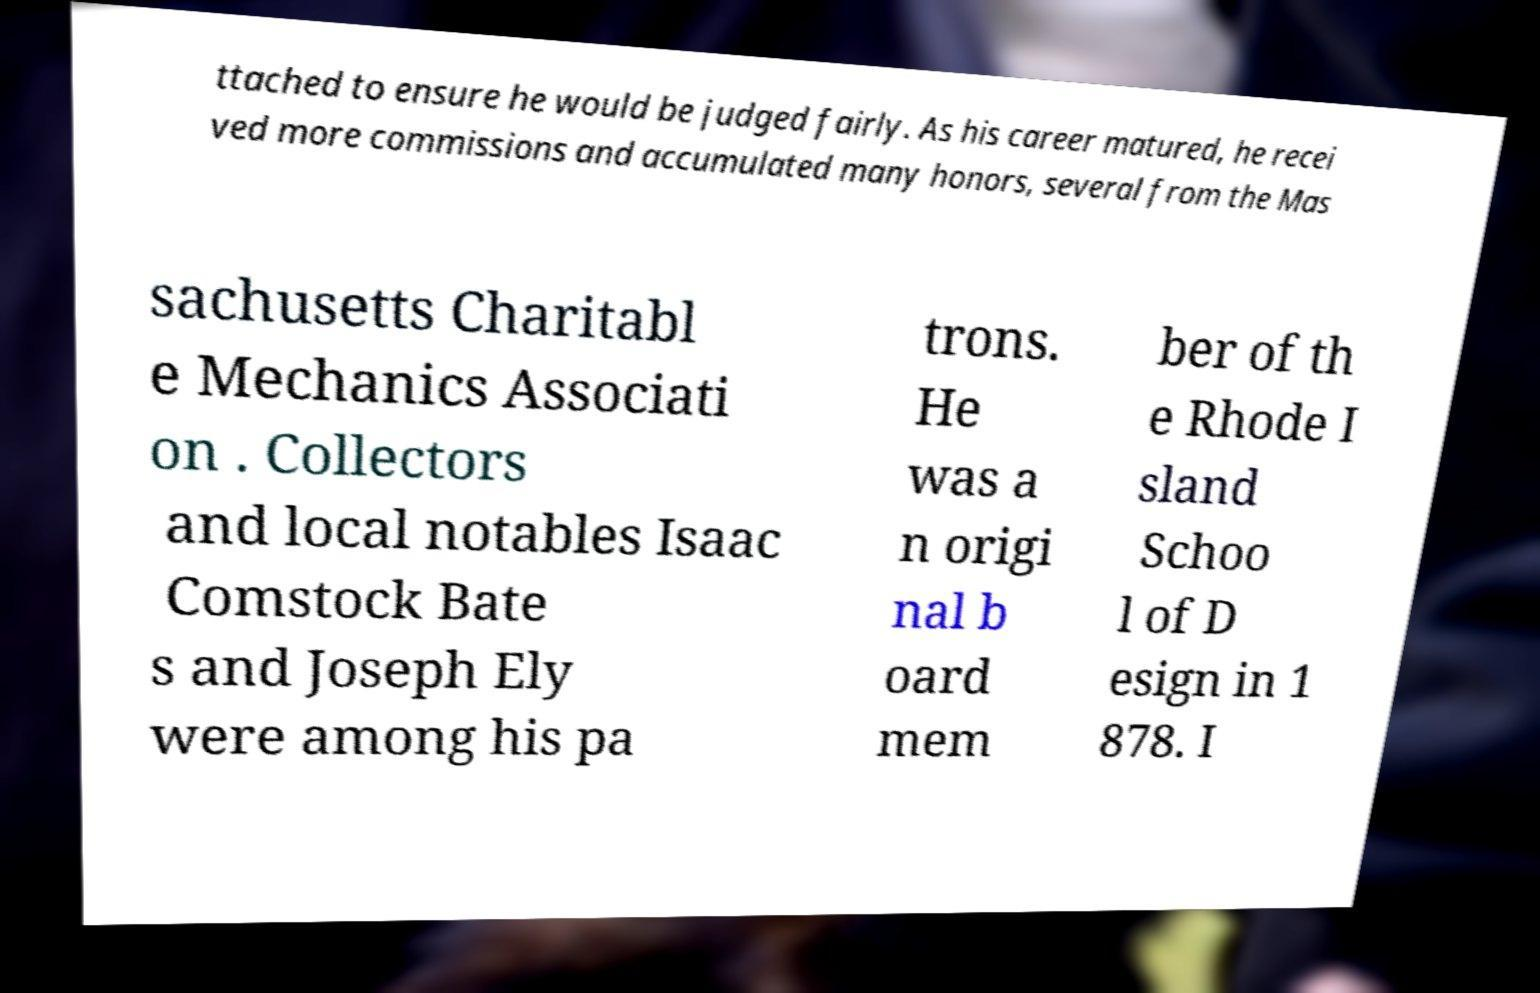Can you read and provide the text displayed in the image?This photo seems to have some interesting text. Can you extract and type it out for me? ttached to ensure he would be judged fairly. As his career matured, he recei ved more commissions and accumulated many honors, several from the Mas sachusetts Charitabl e Mechanics Associati on . Collectors and local notables Isaac Comstock Bate s and Joseph Ely were among his pa trons. He was a n origi nal b oard mem ber of th e Rhode I sland Schoo l of D esign in 1 878. I 